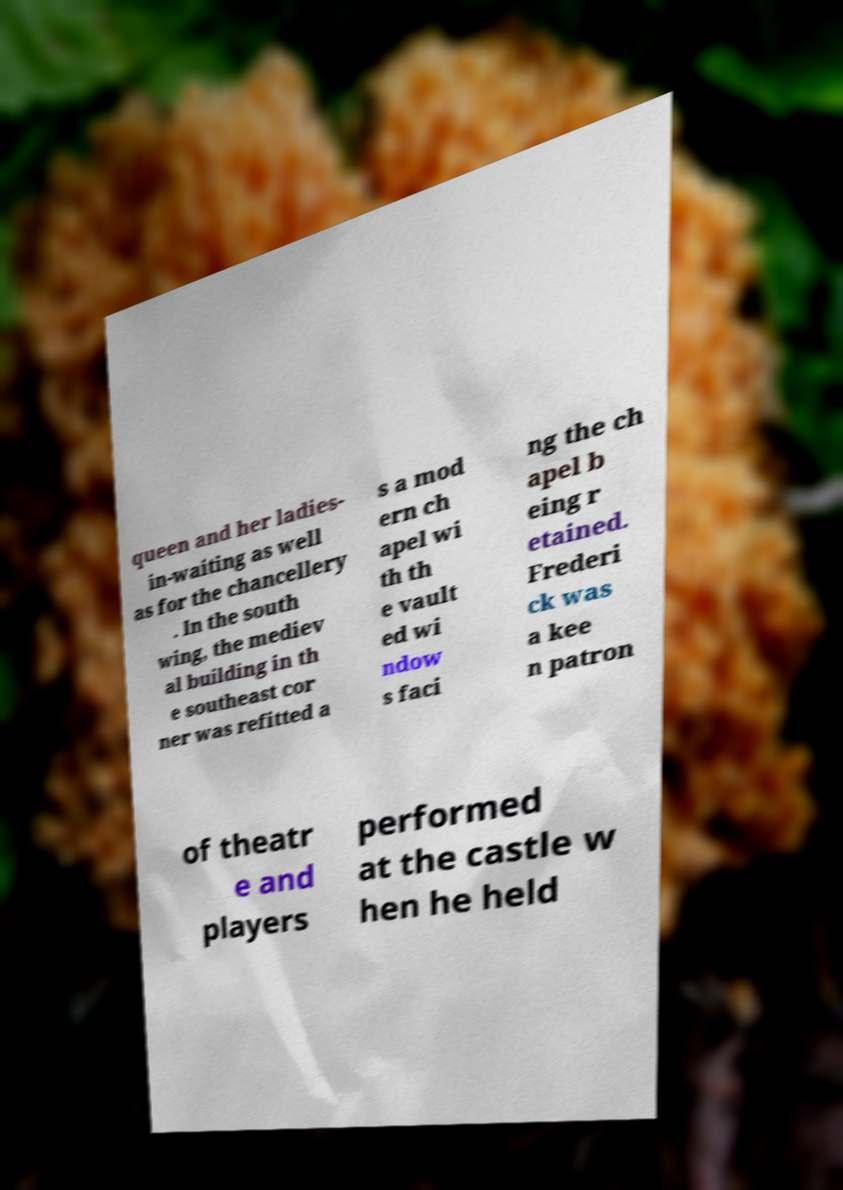There's text embedded in this image that I need extracted. Can you transcribe it verbatim? queen and her ladies- in-waiting as well as for the chancellery . In the south wing, the mediev al building in th e southeast cor ner was refitted a s a mod ern ch apel wi th th e vault ed wi ndow s faci ng the ch apel b eing r etained. Frederi ck was a kee n patron of theatr e and players performed at the castle w hen he held 